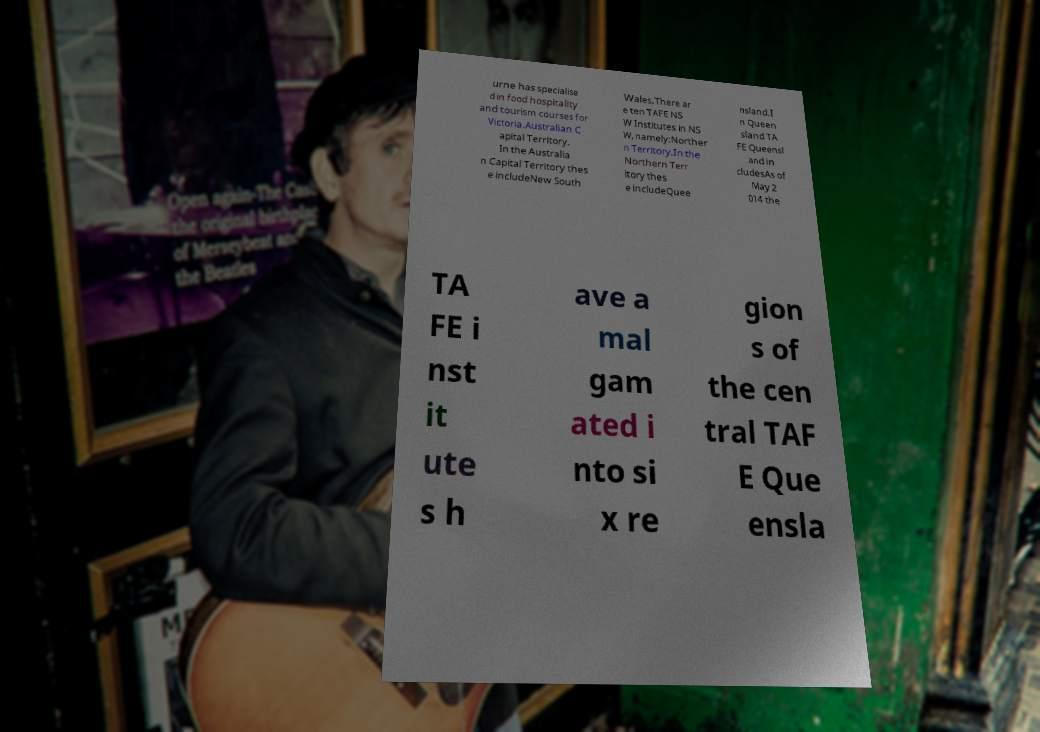Could you extract and type out the text from this image? urne has specialise d in food hospitality and tourism courses for Victoria.Australian C apital Territory. In the Australia n Capital Territory thes e includeNew South Wales.There ar e ten TAFE NS W Institutes in NS W, namely:Norther n Territory.In the Northern Terr itory thes e includeQuee nsland.I n Queen sland TA FE Queensl and in cludesAs of May 2 014 the TA FE i nst it ute s h ave a mal gam ated i nto si x re gion s of the cen tral TAF E Que ensla 